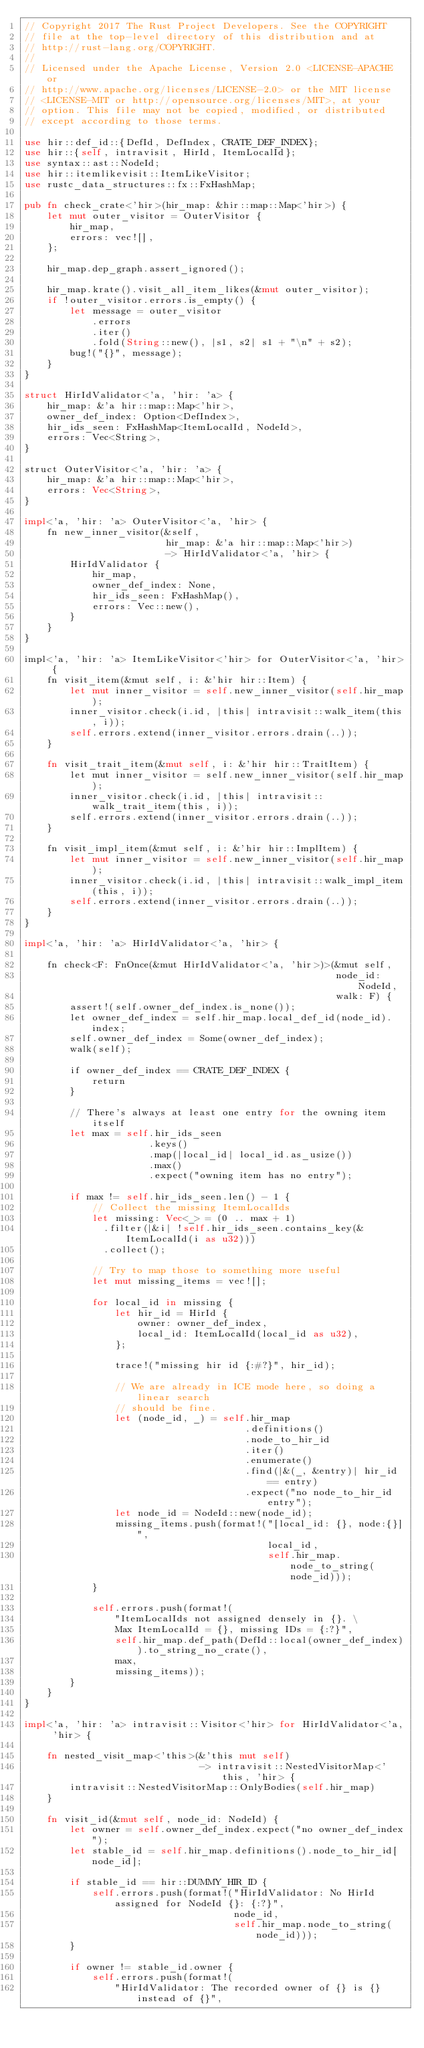Convert code to text. <code><loc_0><loc_0><loc_500><loc_500><_Rust_>// Copyright 2017 The Rust Project Developers. See the COPYRIGHT
// file at the top-level directory of this distribution and at
// http://rust-lang.org/COPYRIGHT.
//
// Licensed under the Apache License, Version 2.0 <LICENSE-APACHE or
// http://www.apache.org/licenses/LICENSE-2.0> or the MIT license
// <LICENSE-MIT or http://opensource.org/licenses/MIT>, at your
// option. This file may not be copied, modified, or distributed
// except according to those terms.

use hir::def_id::{DefId, DefIndex, CRATE_DEF_INDEX};
use hir::{self, intravisit, HirId, ItemLocalId};
use syntax::ast::NodeId;
use hir::itemlikevisit::ItemLikeVisitor;
use rustc_data_structures::fx::FxHashMap;

pub fn check_crate<'hir>(hir_map: &hir::map::Map<'hir>) {
    let mut outer_visitor = OuterVisitor {
        hir_map,
        errors: vec![],
    };

    hir_map.dep_graph.assert_ignored();

    hir_map.krate().visit_all_item_likes(&mut outer_visitor);
    if !outer_visitor.errors.is_empty() {
        let message = outer_visitor
            .errors
            .iter()
            .fold(String::new(), |s1, s2| s1 + "\n" + s2);
        bug!("{}", message);
    }
}

struct HirIdValidator<'a, 'hir: 'a> {
    hir_map: &'a hir::map::Map<'hir>,
    owner_def_index: Option<DefIndex>,
    hir_ids_seen: FxHashMap<ItemLocalId, NodeId>,
    errors: Vec<String>,
}

struct OuterVisitor<'a, 'hir: 'a> {
    hir_map: &'a hir::map::Map<'hir>,
    errors: Vec<String>,
}

impl<'a, 'hir: 'a> OuterVisitor<'a, 'hir> {
    fn new_inner_visitor(&self,
                         hir_map: &'a hir::map::Map<'hir>)
                         -> HirIdValidator<'a, 'hir> {
        HirIdValidator {
            hir_map,
            owner_def_index: None,
            hir_ids_seen: FxHashMap(),
            errors: Vec::new(),
        }
    }
}

impl<'a, 'hir: 'a> ItemLikeVisitor<'hir> for OuterVisitor<'a, 'hir> {
    fn visit_item(&mut self, i: &'hir hir::Item) {
        let mut inner_visitor = self.new_inner_visitor(self.hir_map);
        inner_visitor.check(i.id, |this| intravisit::walk_item(this, i));
        self.errors.extend(inner_visitor.errors.drain(..));
    }

    fn visit_trait_item(&mut self, i: &'hir hir::TraitItem) {
        let mut inner_visitor = self.new_inner_visitor(self.hir_map);
        inner_visitor.check(i.id, |this| intravisit::walk_trait_item(this, i));
        self.errors.extend(inner_visitor.errors.drain(..));
    }

    fn visit_impl_item(&mut self, i: &'hir hir::ImplItem) {
        let mut inner_visitor = self.new_inner_visitor(self.hir_map);
        inner_visitor.check(i.id, |this| intravisit::walk_impl_item(this, i));
        self.errors.extend(inner_visitor.errors.drain(..));
    }
}

impl<'a, 'hir: 'a> HirIdValidator<'a, 'hir> {

    fn check<F: FnOnce(&mut HirIdValidator<'a, 'hir>)>(&mut self,
                                                       node_id: NodeId,
                                                       walk: F) {
        assert!(self.owner_def_index.is_none());
        let owner_def_index = self.hir_map.local_def_id(node_id).index;
        self.owner_def_index = Some(owner_def_index);
        walk(self);

        if owner_def_index == CRATE_DEF_INDEX {
            return
        }

        // There's always at least one entry for the owning item itself
        let max = self.hir_ids_seen
                      .keys()
                      .map(|local_id| local_id.as_usize())
                      .max()
                      .expect("owning item has no entry");

        if max != self.hir_ids_seen.len() - 1 {
            // Collect the missing ItemLocalIds
            let missing: Vec<_> = (0 .. max + 1)
              .filter(|&i| !self.hir_ids_seen.contains_key(&ItemLocalId(i as u32)))
              .collect();

            // Try to map those to something more useful
            let mut missing_items = vec![];

            for local_id in missing {
                let hir_id = HirId {
                    owner: owner_def_index,
                    local_id: ItemLocalId(local_id as u32),
                };

                trace!("missing hir id {:#?}", hir_id);

                // We are already in ICE mode here, so doing a linear search
                // should be fine.
                let (node_id, _) = self.hir_map
                                       .definitions()
                                       .node_to_hir_id
                                       .iter()
                                       .enumerate()
                                       .find(|&(_, &entry)| hir_id == entry)
                                       .expect("no node_to_hir_id entry");
                let node_id = NodeId::new(node_id);
                missing_items.push(format!("[local_id: {}, node:{}]",
                                           local_id,
                                           self.hir_map.node_to_string(node_id)));
            }

            self.errors.push(format!(
                "ItemLocalIds not assigned densely in {}. \
                Max ItemLocalId = {}, missing IDs = {:?}",
                self.hir_map.def_path(DefId::local(owner_def_index)).to_string_no_crate(),
                max,
                missing_items));
        }
    }
}

impl<'a, 'hir: 'a> intravisit::Visitor<'hir> for HirIdValidator<'a, 'hir> {

    fn nested_visit_map<'this>(&'this mut self)
                               -> intravisit::NestedVisitorMap<'this, 'hir> {
        intravisit::NestedVisitorMap::OnlyBodies(self.hir_map)
    }

    fn visit_id(&mut self, node_id: NodeId) {
        let owner = self.owner_def_index.expect("no owner_def_index");
        let stable_id = self.hir_map.definitions().node_to_hir_id[node_id];

        if stable_id == hir::DUMMY_HIR_ID {
            self.errors.push(format!("HirIdValidator: No HirId assigned for NodeId {}: {:?}",
                                     node_id,
                                     self.hir_map.node_to_string(node_id)));
        }

        if owner != stable_id.owner {
            self.errors.push(format!(
                "HirIdValidator: The recorded owner of {} is {} instead of {}",</code> 